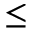<formula> <loc_0><loc_0><loc_500><loc_500>{ \leq }</formula> 